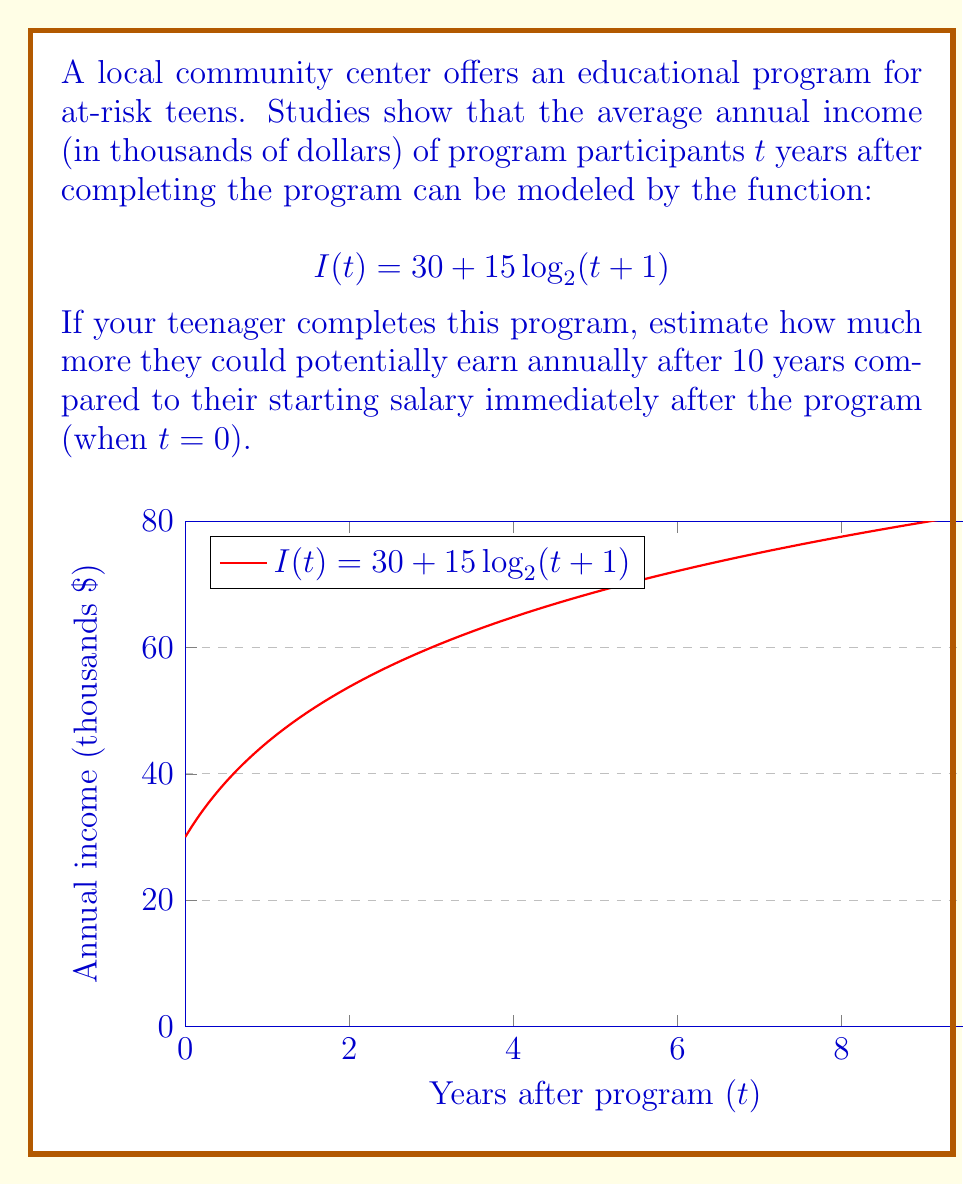Give your solution to this math problem. Let's approach this step-by-step:

1) First, we need to calculate the starting salary when t = 0:
   $I(0) = 30 + 15 \log_2(0+1) = 30 + 15 \log_2(1) = 30 + 15(0) = 30$
   So, the starting salary is $30,000.

2) Now, let's calculate the salary after 10 years (t = 10):
   $I(10) = 30 + 15 \log_2(10+1) = 30 + 15 \log_2(11)$

3) We need to evaluate $\log_2(11)$:
   $\log_2(11) \approx 3.4594$ (using a calculator)

4) Now we can complete our calculation:
   $I(10) = 30 + 15(3.4594) \approx 30 + 51.891 = 81.891$

5) The salary after 10 years is approximately $81,891.

6) To find how much more they could earn, we subtract the starting salary:
   $81.891 - 30 = 51.891$

Therefore, after 10 years, your teenager could potentially earn about $51,891 more annually than their starting salary.
Answer: $51,891 